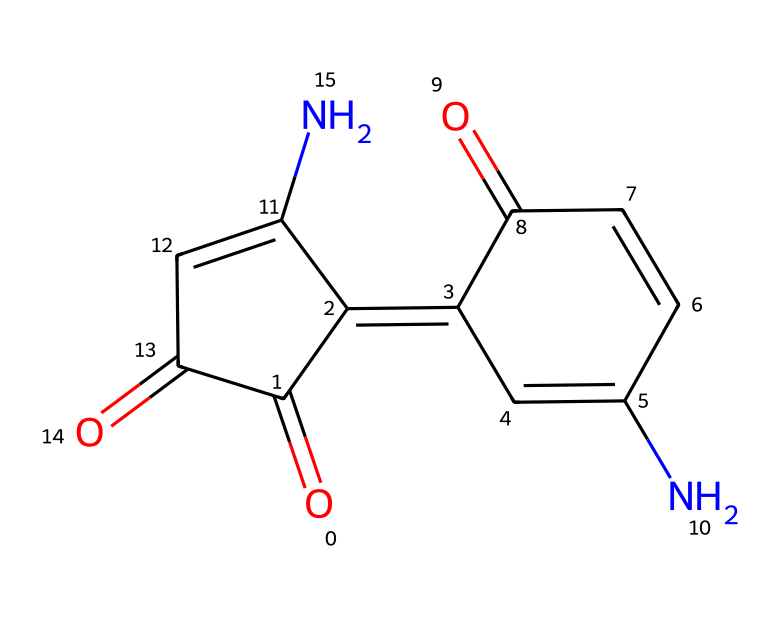What is the molecular formula of indigo dye? Analyzing the structure represented by the SMILES, we can deduce the number of each type of atom present in the molecule. By counting, we find there are 16 carbon atoms, 10 hydrogen atoms, 2 nitrogen atoms, and 4 oxygen atoms. The molecular formula combines these counts as C16H10N2O4.
Answer: C16H10N2O4 How many ring structures are present in this molecule? Looking at the SMILES representation, we can identify the cyclic parts of the molecule, which are indicated by the presence of numbers (1,2) that denote connections in a cyclic manner. There are two distinct ring structures in the indigo dye.
Answer: 2 What type of chemical bonds are predominantly present in indigo dye? The SMILES representation implies multiple types of bonds. By evaluating the connections between the atoms, we can see that the molecule consists mainly of carbon-carbon (C-C), carbon-nitrogen (C-N), carbon-oxygen (C=O), and nitrogen-hydrogen (N-H) bonds, with double bonds present between carbon and oxygen (C=O).
Answer: covalent What functional groups can be identified in indigo dye? From the structure, we can identify key functional groups including carbonyl (C=O) and amine (N-H) groups. These groups are pivotal in determining the chemical properties of the dye. Thus, the prominent functional groups are carbonyls and amines.
Answer: carbonyl, amine How many nitrogen atoms are present in this dye molecule? The structure indicates two nitrogen atoms are included in the indigo molecule, as seen in the SMILES representation where nitrogen (N) is present at two different points. Thus, the answer is straightforward.
Answer: 2 What is the main color of the dye produced from indigo? The color of the dye, derived from its molecular structure and characteristics, is consistently recognized for yielding a dramatic blue hue when used in textiles. This is a well-known attribute of indigo dye.
Answer: blue 